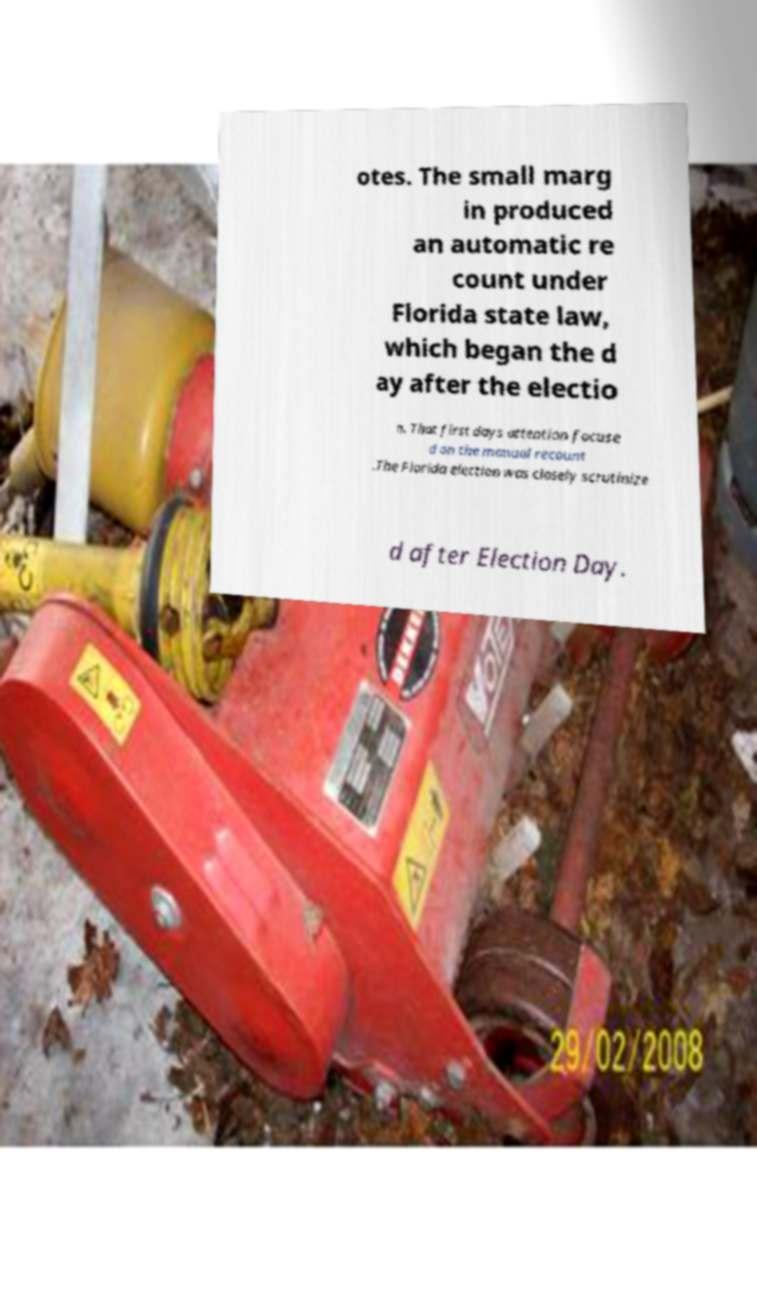For documentation purposes, I need the text within this image transcribed. Could you provide that? otes. The small marg in produced an automatic re count under Florida state law, which began the d ay after the electio n. That first days attention focuse d on the manual recount .The Florida election was closely scrutinize d after Election Day. 